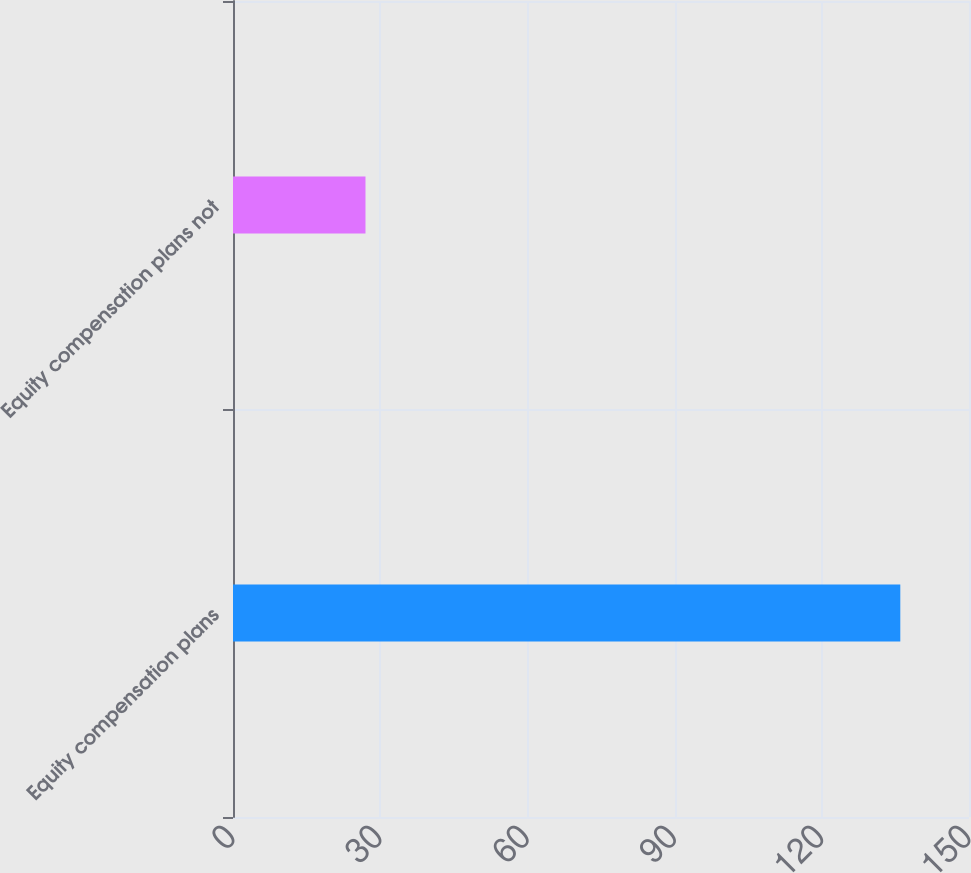<chart> <loc_0><loc_0><loc_500><loc_500><bar_chart><fcel>Equity compensation plans<fcel>Equity compensation plans not<nl><fcel>136<fcel>27<nl></chart> 